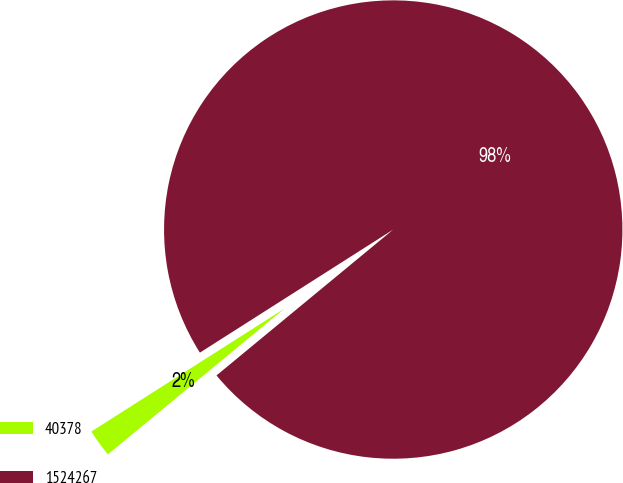<chart> <loc_0><loc_0><loc_500><loc_500><pie_chart><fcel>40378<fcel>1524267<nl><fcel>1.96%<fcel>98.04%<nl></chart> 